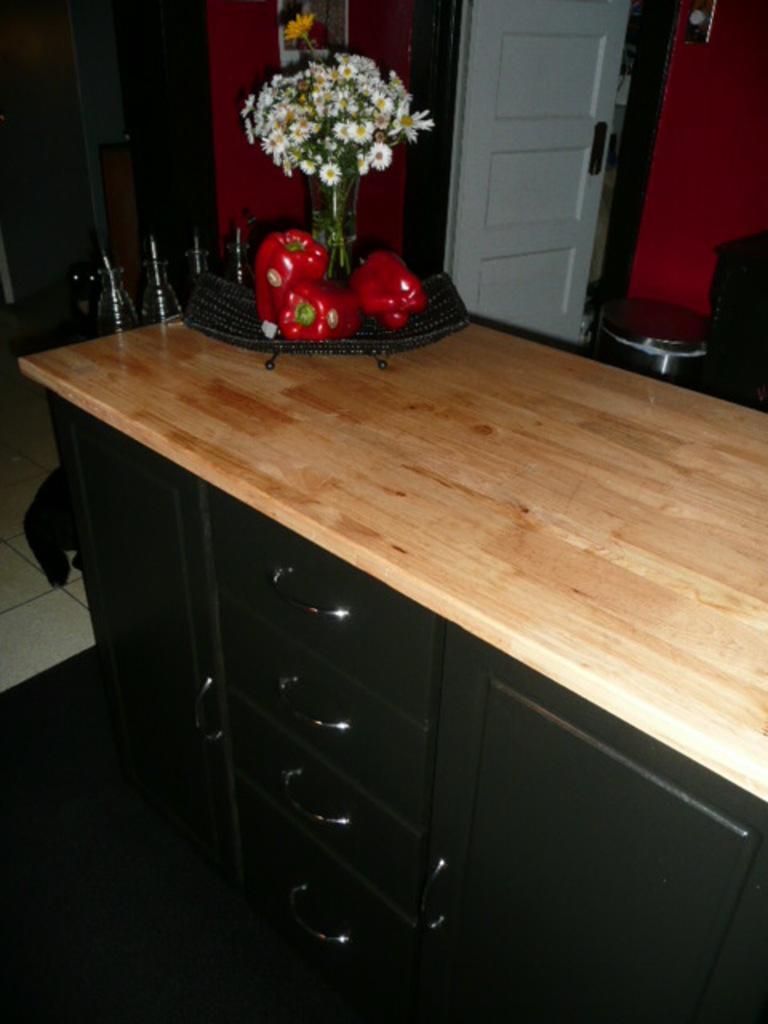Could you give a brief overview of what you see in this image? In the middle there is a drawer on that drawer there are some vegetables and flower vase. In the background there is a door and wall. 